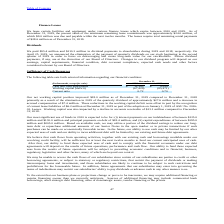According to Consolidated Communications Holdings's financial document, What was net working capital position improvement in 2019 compared to 2018? According to the financial document, $18.0 million. The relevant text states: "Our net working capital position improved $18.0 million as of December 31, 2019 compared to December 31, 2018 primarily as a result of the elimination in 20..." Also, What was the quarterly dividend elimination value in 2019? According to the financial document, $27.6 million. The relevant text states: "in 2019 of the quarterly dividend of approximately $27.6 million and a decrease in accrued compensation of $7.4 million. These reductions in the working capital defi..." Also, What was the current lease liability in 2019? According to the financial document, $6.2 million. The relevant text states: "by the recognition of current lease liabilities of $6.2 million at December 31, 2019 as part of the adoption on January 1, 2019 of ASU No. 2016- 02, Leases. Working..." Also, can you calculate: What was the increase / (decrease) in the cash and cash equivalent from 2018 to 2019? Based on the calculation: 12,395 - 9,599, the result is 2796 (in thousands). This is based on the information: "Cash and cash equivalents $ 12,395 $ 9,599 Cash and cash equivalents $ 12,395 $ 9,599..." The key data points involved are: 12,395, 9,599. Also, can you calculate: What was the average working capital deficit for 2018 to 2019? To answer this question, I need to perform calculations using the financial data. The calculation is: -(67,429 + 85,471) / 2, which equals -76450 (in thousands). This is based on the information: "Working capital (deficit) (67,429) (85,471) Working capital (deficit) (67,429) (85,471)..." The key data points involved are: 67,429, 85,471. Also, can you calculate: What was the increase / (decrease) in the current ratio from 2018 to 2019? Based on the calculation: 0.72 - 0.70, the result is 0.02. This is based on the information: "Current ratio 0.72 0.70 Current ratio 0.72 0.70..." The key data points involved are: 0.70, 0.72. 